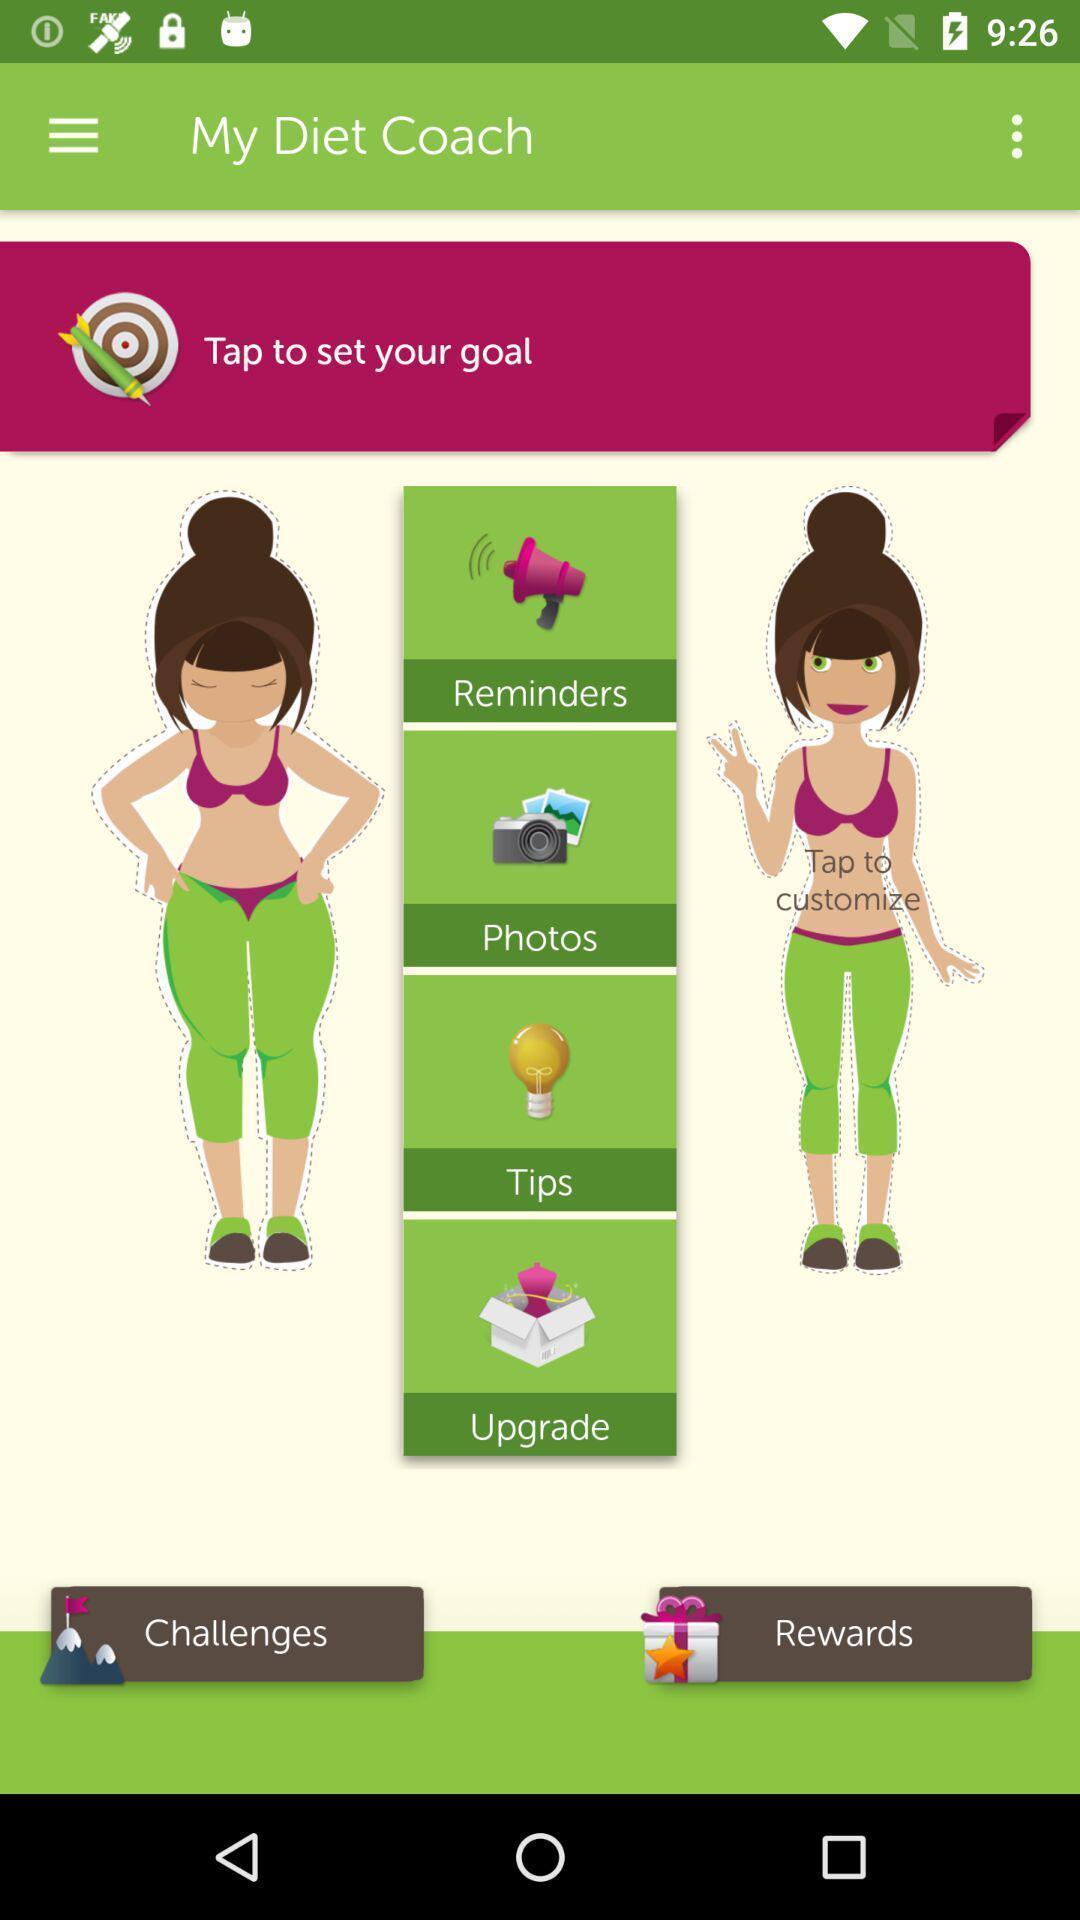Describe the visual elements of this screenshot. Screen displaying multiple options with pictures in a dieting application. 